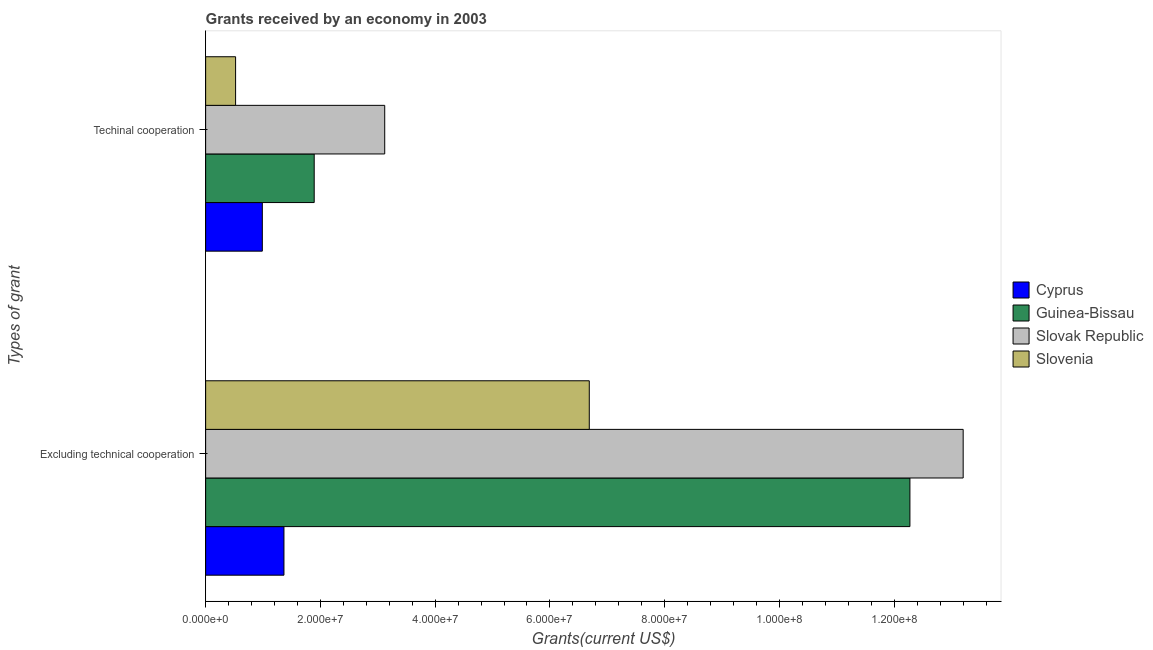How many different coloured bars are there?
Your answer should be very brief. 4. How many groups of bars are there?
Give a very brief answer. 2. Are the number of bars on each tick of the Y-axis equal?
Your response must be concise. Yes. What is the label of the 2nd group of bars from the top?
Keep it short and to the point. Excluding technical cooperation. What is the amount of grants received(including technical cooperation) in Slovak Republic?
Your answer should be compact. 3.12e+07. Across all countries, what is the maximum amount of grants received(including technical cooperation)?
Keep it short and to the point. 3.12e+07. Across all countries, what is the minimum amount of grants received(excluding technical cooperation)?
Your answer should be compact. 1.36e+07. In which country was the amount of grants received(including technical cooperation) maximum?
Offer a very short reply. Slovak Republic. In which country was the amount of grants received(excluding technical cooperation) minimum?
Offer a terse response. Cyprus. What is the total amount of grants received(excluding technical cooperation) in the graph?
Ensure brevity in your answer.  3.35e+08. What is the difference between the amount of grants received(excluding technical cooperation) in Cyprus and that in Slovak Republic?
Your response must be concise. -1.18e+08. What is the difference between the amount of grants received(excluding technical cooperation) in Cyprus and the amount of grants received(including technical cooperation) in Slovak Republic?
Offer a terse response. -1.76e+07. What is the average amount of grants received(including technical cooperation) per country?
Your response must be concise. 1.63e+07. What is the difference between the amount of grants received(including technical cooperation) and amount of grants received(excluding technical cooperation) in Cyprus?
Offer a very short reply. -3.77e+06. What is the ratio of the amount of grants received(excluding technical cooperation) in Guinea-Bissau to that in Slovenia?
Make the answer very short. 1.84. Is the amount of grants received(excluding technical cooperation) in Slovenia less than that in Guinea-Bissau?
Keep it short and to the point. Yes. In how many countries, is the amount of grants received(including technical cooperation) greater than the average amount of grants received(including technical cooperation) taken over all countries?
Offer a very short reply. 2. What does the 4th bar from the top in Excluding technical cooperation represents?
Give a very brief answer. Cyprus. What does the 4th bar from the bottom in Excluding technical cooperation represents?
Make the answer very short. Slovenia. What is the difference between two consecutive major ticks on the X-axis?
Provide a short and direct response. 2.00e+07. Are the values on the major ticks of X-axis written in scientific E-notation?
Offer a terse response. Yes. Does the graph contain any zero values?
Your answer should be very brief. No. Where does the legend appear in the graph?
Give a very brief answer. Center right. How many legend labels are there?
Give a very brief answer. 4. What is the title of the graph?
Keep it short and to the point. Grants received by an economy in 2003. Does "Cayman Islands" appear as one of the legend labels in the graph?
Your response must be concise. No. What is the label or title of the X-axis?
Keep it short and to the point. Grants(current US$). What is the label or title of the Y-axis?
Provide a short and direct response. Types of grant. What is the Grants(current US$) of Cyprus in Excluding technical cooperation?
Provide a succinct answer. 1.36e+07. What is the Grants(current US$) of Guinea-Bissau in Excluding technical cooperation?
Give a very brief answer. 1.23e+08. What is the Grants(current US$) in Slovak Republic in Excluding technical cooperation?
Provide a succinct answer. 1.32e+08. What is the Grants(current US$) of Slovenia in Excluding technical cooperation?
Provide a succinct answer. 6.69e+07. What is the Grants(current US$) in Cyprus in Techinal cooperation?
Your answer should be very brief. 9.88e+06. What is the Grants(current US$) in Guinea-Bissau in Techinal cooperation?
Your answer should be compact. 1.89e+07. What is the Grants(current US$) of Slovak Republic in Techinal cooperation?
Provide a succinct answer. 3.12e+07. What is the Grants(current US$) of Slovenia in Techinal cooperation?
Offer a very short reply. 5.22e+06. Across all Types of grant, what is the maximum Grants(current US$) in Cyprus?
Give a very brief answer. 1.36e+07. Across all Types of grant, what is the maximum Grants(current US$) in Guinea-Bissau?
Your answer should be very brief. 1.23e+08. Across all Types of grant, what is the maximum Grants(current US$) in Slovak Republic?
Provide a short and direct response. 1.32e+08. Across all Types of grant, what is the maximum Grants(current US$) of Slovenia?
Provide a succinct answer. 6.69e+07. Across all Types of grant, what is the minimum Grants(current US$) in Cyprus?
Provide a short and direct response. 9.88e+06. Across all Types of grant, what is the minimum Grants(current US$) in Guinea-Bissau?
Make the answer very short. 1.89e+07. Across all Types of grant, what is the minimum Grants(current US$) of Slovak Republic?
Ensure brevity in your answer.  3.12e+07. Across all Types of grant, what is the minimum Grants(current US$) in Slovenia?
Provide a short and direct response. 5.22e+06. What is the total Grants(current US$) in Cyprus in the graph?
Give a very brief answer. 2.35e+07. What is the total Grants(current US$) in Guinea-Bissau in the graph?
Provide a short and direct response. 1.42e+08. What is the total Grants(current US$) in Slovak Republic in the graph?
Offer a very short reply. 1.63e+08. What is the total Grants(current US$) of Slovenia in the graph?
Give a very brief answer. 7.21e+07. What is the difference between the Grants(current US$) of Cyprus in Excluding technical cooperation and that in Techinal cooperation?
Offer a terse response. 3.77e+06. What is the difference between the Grants(current US$) in Guinea-Bissau in Excluding technical cooperation and that in Techinal cooperation?
Your answer should be very brief. 1.04e+08. What is the difference between the Grants(current US$) in Slovak Republic in Excluding technical cooperation and that in Techinal cooperation?
Provide a short and direct response. 1.01e+08. What is the difference between the Grants(current US$) of Slovenia in Excluding technical cooperation and that in Techinal cooperation?
Keep it short and to the point. 6.16e+07. What is the difference between the Grants(current US$) of Cyprus in Excluding technical cooperation and the Grants(current US$) of Guinea-Bissau in Techinal cooperation?
Your answer should be compact. -5.27e+06. What is the difference between the Grants(current US$) of Cyprus in Excluding technical cooperation and the Grants(current US$) of Slovak Republic in Techinal cooperation?
Ensure brevity in your answer.  -1.76e+07. What is the difference between the Grants(current US$) of Cyprus in Excluding technical cooperation and the Grants(current US$) of Slovenia in Techinal cooperation?
Provide a succinct answer. 8.43e+06. What is the difference between the Grants(current US$) of Guinea-Bissau in Excluding technical cooperation and the Grants(current US$) of Slovak Republic in Techinal cooperation?
Offer a very short reply. 9.15e+07. What is the difference between the Grants(current US$) in Guinea-Bissau in Excluding technical cooperation and the Grants(current US$) in Slovenia in Techinal cooperation?
Your answer should be compact. 1.18e+08. What is the difference between the Grants(current US$) of Slovak Republic in Excluding technical cooperation and the Grants(current US$) of Slovenia in Techinal cooperation?
Your answer should be very brief. 1.27e+08. What is the average Grants(current US$) of Cyprus per Types of grant?
Your response must be concise. 1.18e+07. What is the average Grants(current US$) of Guinea-Bissau per Types of grant?
Your answer should be very brief. 7.08e+07. What is the average Grants(current US$) in Slovak Republic per Types of grant?
Your answer should be very brief. 8.16e+07. What is the average Grants(current US$) of Slovenia per Types of grant?
Offer a very short reply. 3.60e+07. What is the difference between the Grants(current US$) in Cyprus and Grants(current US$) in Guinea-Bissau in Excluding technical cooperation?
Ensure brevity in your answer.  -1.09e+08. What is the difference between the Grants(current US$) in Cyprus and Grants(current US$) in Slovak Republic in Excluding technical cooperation?
Your answer should be compact. -1.18e+08. What is the difference between the Grants(current US$) in Cyprus and Grants(current US$) in Slovenia in Excluding technical cooperation?
Your response must be concise. -5.32e+07. What is the difference between the Grants(current US$) of Guinea-Bissau and Grants(current US$) of Slovak Republic in Excluding technical cooperation?
Give a very brief answer. -9.28e+06. What is the difference between the Grants(current US$) in Guinea-Bissau and Grants(current US$) in Slovenia in Excluding technical cooperation?
Offer a terse response. 5.59e+07. What is the difference between the Grants(current US$) in Slovak Republic and Grants(current US$) in Slovenia in Excluding technical cooperation?
Your answer should be compact. 6.52e+07. What is the difference between the Grants(current US$) of Cyprus and Grants(current US$) of Guinea-Bissau in Techinal cooperation?
Your response must be concise. -9.04e+06. What is the difference between the Grants(current US$) in Cyprus and Grants(current US$) in Slovak Republic in Techinal cooperation?
Keep it short and to the point. -2.13e+07. What is the difference between the Grants(current US$) in Cyprus and Grants(current US$) in Slovenia in Techinal cooperation?
Your response must be concise. 4.66e+06. What is the difference between the Grants(current US$) of Guinea-Bissau and Grants(current US$) of Slovak Republic in Techinal cooperation?
Your answer should be very brief. -1.23e+07. What is the difference between the Grants(current US$) of Guinea-Bissau and Grants(current US$) of Slovenia in Techinal cooperation?
Ensure brevity in your answer.  1.37e+07. What is the difference between the Grants(current US$) of Slovak Republic and Grants(current US$) of Slovenia in Techinal cooperation?
Make the answer very short. 2.60e+07. What is the ratio of the Grants(current US$) of Cyprus in Excluding technical cooperation to that in Techinal cooperation?
Provide a short and direct response. 1.38. What is the ratio of the Grants(current US$) of Guinea-Bissau in Excluding technical cooperation to that in Techinal cooperation?
Give a very brief answer. 6.49. What is the ratio of the Grants(current US$) of Slovak Republic in Excluding technical cooperation to that in Techinal cooperation?
Ensure brevity in your answer.  4.23. What is the ratio of the Grants(current US$) in Slovenia in Excluding technical cooperation to that in Techinal cooperation?
Provide a short and direct response. 12.81. What is the difference between the highest and the second highest Grants(current US$) of Cyprus?
Your answer should be compact. 3.77e+06. What is the difference between the highest and the second highest Grants(current US$) in Guinea-Bissau?
Provide a short and direct response. 1.04e+08. What is the difference between the highest and the second highest Grants(current US$) of Slovak Republic?
Provide a succinct answer. 1.01e+08. What is the difference between the highest and the second highest Grants(current US$) in Slovenia?
Make the answer very short. 6.16e+07. What is the difference between the highest and the lowest Grants(current US$) of Cyprus?
Keep it short and to the point. 3.77e+06. What is the difference between the highest and the lowest Grants(current US$) in Guinea-Bissau?
Provide a succinct answer. 1.04e+08. What is the difference between the highest and the lowest Grants(current US$) of Slovak Republic?
Ensure brevity in your answer.  1.01e+08. What is the difference between the highest and the lowest Grants(current US$) of Slovenia?
Your response must be concise. 6.16e+07. 